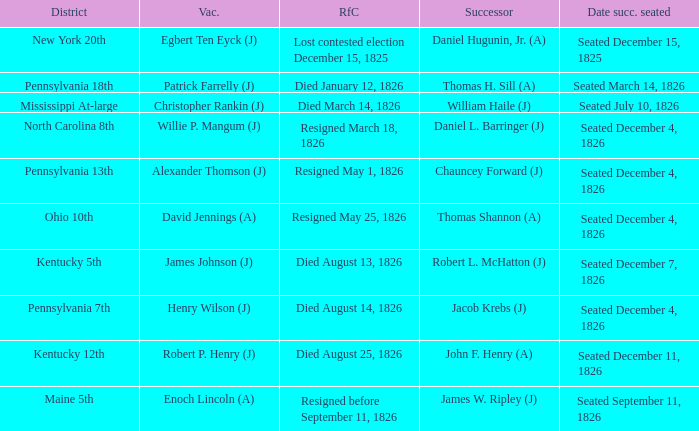Name the reason for change pennsylvania 13th Resigned May 1, 1826. 